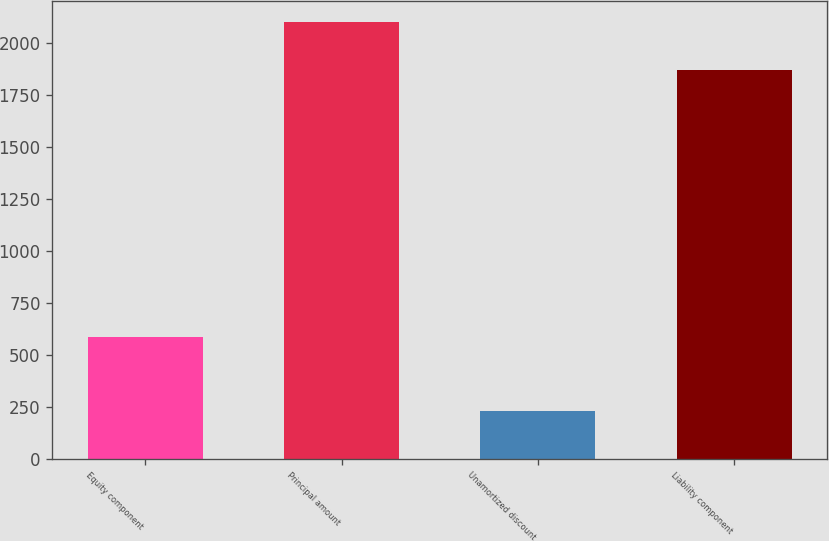Convert chart to OTSL. <chart><loc_0><loc_0><loc_500><loc_500><bar_chart><fcel>Equity component<fcel>Principal amount<fcel>Unamortized discount<fcel>Liability component<nl><fcel>586<fcel>2100<fcel>229<fcel>1871<nl></chart> 